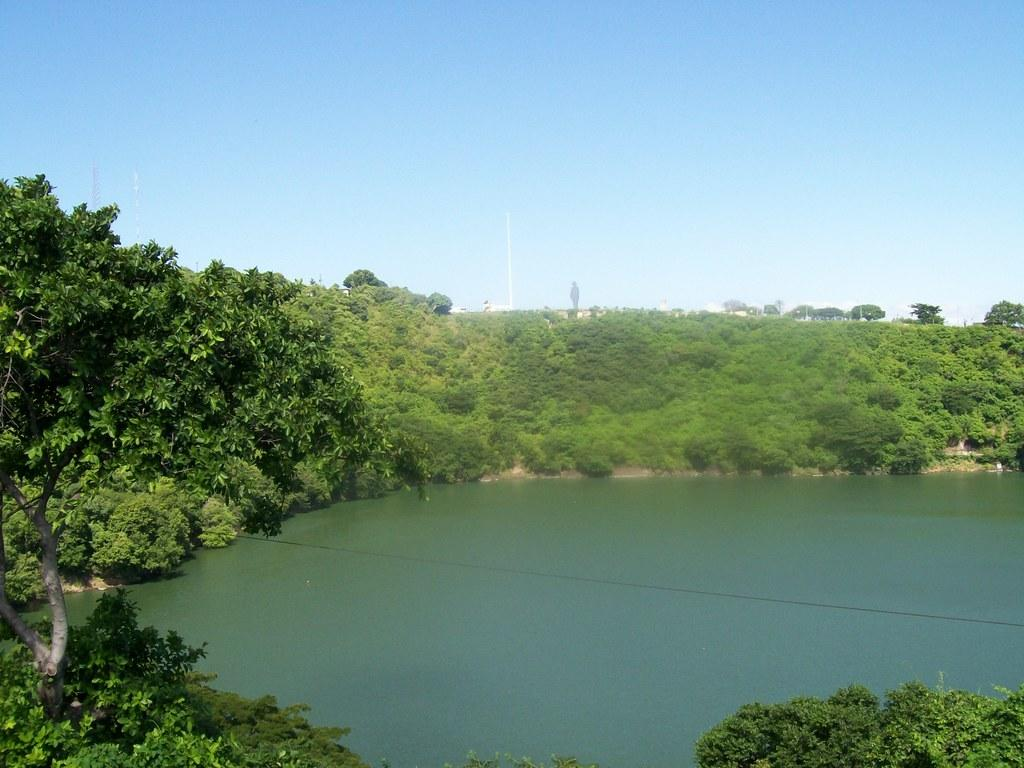What type of vegetation can be seen in the image? There are trees in the image. What natural element is visible in the image? There is water visible in the image. What is the condition of the sky in the image? The sky appears to be cloudy in the image. What object can be seen standing upright in the image? There is a pole in the image. What type of cover is being used to protect the trees in the image? There is no cover visible in the image; the trees are not protected by any cover. What type of cable can be seen connecting the water and the sky in the image? There is no cable connecting the water and the sky in the image; it is a natural scene without any artificial elements. 